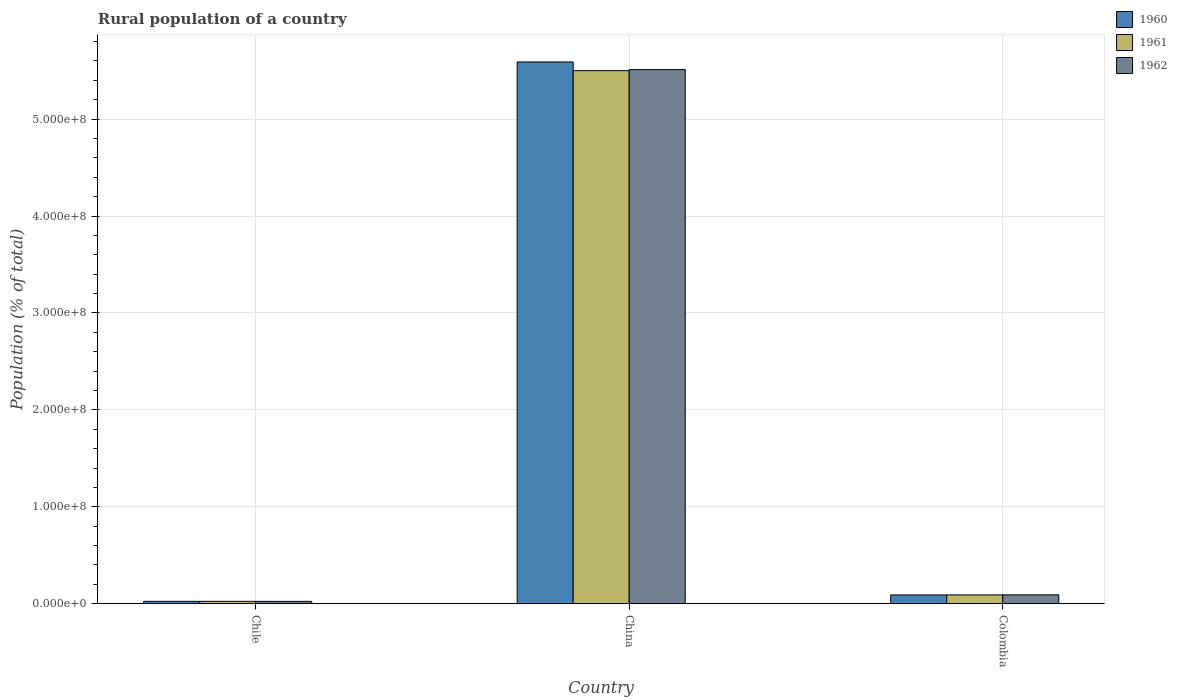How many different coloured bars are there?
Offer a terse response. 3. How many groups of bars are there?
Keep it short and to the point. 3. How many bars are there on the 3rd tick from the left?
Provide a succinct answer. 3. How many bars are there on the 1st tick from the right?
Offer a terse response. 3. What is the label of the 1st group of bars from the left?
Your answer should be compact. Chile. In how many cases, is the number of bars for a given country not equal to the number of legend labels?
Ensure brevity in your answer.  0. What is the rural population in 1961 in China?
Offer a terse response. 5.50e+08. Across all countries, what is the maximum rural population in 1962?
Provide a succinct answer. 5.51e+08. Across all countries, what is the minimum rural population in 1961?
Offer a terse response. 2.47e+06. In which country was the rural population in 1962 maximum?
Your answer should be very brief. China. In which country was the rural population in 1960 minimum?
Provide a succinct answer. Chile. What is the total rural population in 1962 in the graph?
Keep it short and to the point. 5.63e+08. What is the difference between the rural population in 1960 in Chile and that in China?
Offer a very short reply. -5.57e+08. What is the difference between the rural population in 1961 in Chile and the rural population in 1962 in China?
Give a very brief answer. -5.49e+08. What is the average rural population in 1960 per country?
Offer a very short reply. 1.90e+08. What is the difference between the rural population of/in 1962 and rural population of/in 1960 in Chile?
Your answer should be compact. -1.35e+04. In how many countries, is the rural population in 1962 greater than 160000000 %?
Your response must be concise. 1. What is the ratio of the rural population in 1960 in Chile to that in Colombia?
Provide a succinct answer. 0.27. Is the rural population in 1960 in China less than that in Colombia?
Offer a very short reply. No. Is the difference between the rural population in 1962 in China and Colombia greater than the difference between the rural population in 1960 in China and Colombia?
Provide a short and direct response. No. What is the difference between the highest and the second highest rural population in 1960?
Make the answer very short. 5.57e+08. What is the difference between the highest and the lowest rural population in 1960?
Keep it short and to the point. 5.57e+08. Is the sum of the rural population in 1961 in Chile and Colombia greater than the maximum rural population in 1960 across all countries?
Ensure brevity in your answer.  No. Are all the bars in the graph horizontal?
Make the answer very short. No. How many countries are there in the graph?
Provide a short and direct response. 3. Are the values on the major ticks of Y-axis written in scientific E-notation?
Provide a short and direct response. Yes. What is the title of the graph?
Provide a succinct answer. Rural population of a country. What is the label or title of the Y-axis?
Keep it short and to the point. Population (% of total). What is the Population (% of total) of 1960 in Chile?
Your answer should be very brief. 2.48e+06. What is the Population (% of total) of 1961 in Chile?
Offer a very short reply. 2.47e+06. What is the Population (% of total) of 1962 in Chile?
Keep it short and to the point. 2.46e+06. What is the Population (% of total) in 1960 in China?
Your response must be concise. 5.59e+08. What is the Population (% of total) in 1961 in China?
Your response must be concise. 5.50e+08. What is the Population (% of total) of 1962 in China?
Provide a succinct answer. 5.51e+08. What is the Population (% of total) in 1960 in Colombia?
Provide a succinct answer. 9.06e+06. What is the Population (% of total) in 1961 in Colombia?
Your answer should be compact. 9.11e+06. What is the Population (% of total) in 1962 in Colombia?
Ensure brevity in your answer.  9.17e+06. Across all countries, what is the maximum Population (% of total) of 1960?
Your response must be concise. 5.59e+08. Across all countries, what is the maximum Population (% of total) of 1961?
Provide a short and direct response. 5.50e+08. Across all countries, what is the maximum Population (% of total) in 1962?
Keep it short and to the point. 5.51e+08. Across all countries, what is the minimum Population (% of total) of 1960?
Your answer should be very brief. 2.48e+06. Across all countries, what is the minimum Population (% of total) in 1961?
Offer a terse response. 2.47e+06. Across all countries, what is the minimum Population (% of total) of 1962?
Make the answer very short. 2.46e+06. What is the total Population (% of total) of 1960 in the graph?
Offer a very short reply. 5.71e+08. What is the total Population (% of total) in 1961 in the graph?
Offer a very short reply. 5.62e+08. What is the total Population (% of total) of 1962 in the graph?
Offer a very short reply. 5.63e+08. What is the difference between the Population (% of total) of 1960 in Chile and that in China?
Your answer should be very brief. -5.57e+08. What is the difference between the Population (% of total) of 1961 in Chile and that in China?
Make the answer very short. -5.48e+08. What is the difference between the Population (% of total) of 1962 in Chile and that in China?
Your answer should be compact. -5.49e+08. What is the difference between the Population (% of total) of 1960 in Chile and that in Colombia?
Provide a short and direct response. -6.58e+06. What is the difference between the Population (% of total) of 1961 in Chile and that in Colombia?
Your response must be concise. -6.65e+06. What is the difference between the Population (% of total) of 1962 in Chile and that in Colombia?
Keep it short and to the point. -6.70e+06. What is the difference between the Population (% of total) in 1960 in China and that in Colombia?
Provide a short and direct response. 5.50e+08. What is the difference between the Population (% of total) of 1961 in China and that in Colombia?
Provide a succinct answer. 5.41e+08. What is the difference between the Population (% of total) of 1962 in China and that in Colombia?
Ensure brevity in your answer.  5.42e+08. What is the difference between the Population (% of total) of 1960 in Chile and the Population (% of total) of 1961 in China?
Keep it short and to the point. -5.48e+08. What is the difference between the Population (% of total) of 1960 in Chile and the Population (% of total) of 1962 in China?
Your response must be concise. -5.49e+08. What is the difference between the Population (% of total) in 1961 in Chile and the Population (% of total) in 1962 in China?
Your answer should be very brief. -5.49e+08. What is the difference between the Population (% of total) of 1960 in Chile and the Population (% of total) of 1961 in Colombia?
Your answer should be compact. -6.64e+06. What is the difference between the Population (% of total) in 1960 in Chile and the Population (% of total) in 1962 in Colombia?
Provide a succinct answer. -6.69e+06. What is the difference between the Population (% of total) in 1961 in Chile and the Population (% of total) in 1962 in Colombia?
Give a very brief answer. -6.70e+06. What is the difference between the Population (% of total) of 1960 in China and the Population (% of total) of 1961 in Colombia?
Your answer should be very brief. 5.50e+08. What is the difference between the Population (% of total) in 1960 in China and the Population (% of total) in 1962 in Colombia?
Give a very brief answer. 5.50e+08. What is the difference between the Population (% of total) of 1961 in China and the Population (% of total) of 1962 in Colombia?
Provide a succinct answer. 5.41e+08. What is the average Population (% of total) of 1960 per country?
Give a very brief answer. 1.90e+08. What is the average Population (% of total) in 1961 per country?
Provide a short and direct response. 1.87e+08. What is the average Population (% of total) of 1962 per country?
Provide a succinct answer. 1.88e+08. What is the difference between the Population (% of total) in 1960 and Population (% of total) in 1961 in Chile?
Keep it short and to the point. 7686. What is the difference between the Population (% of total) in 1960 and Population (% of total) in 1962 in Chile?
Make the answer very short. 1.35e+04. What is the difference between the Population (% of total) in 1961 and Population (% of total) in 1962 in Chile?
Provide a succinct answer. 5800. What is the difference between the Population (% of total) of 1960 and Population (% of total) of 1961 in China?
Your answer should be very brief. 8.98e+06. What is the difference between the Population (% of total) in 1960 and Population (% of total) in 1962 in China?
Offer a terse response. 7.90e+06. What is the difference between the Population (% of total) of 1961 and Population (% of total) of 1962 in China?
Your response must be concise. -1.08e+06. What is the difference between the Population (% of total) of 1960 and Population (% of total) of 1961 in Colombia?
Your response must be concise. -5.61e+04. What is the difference between the Population (% of total) of 1960 and Population (% of total) of 1962 in Colombia?
Provide a short and direct response. -1.06e+05. What is the difference between the Population (% of total) of 1961 and Population (% of total) of 1962 in Colombia?
Offer a very short reply. -5.03e+04. What is the ratio of the Population (% of total) in 1960 in Chile to that in China?
Ensure brevity in your answer.  0. What is the ratio of the Population (% of total) in 1961 in Chile to that in China?
Make the answer very short. 0. What is the ratio of the Population (% of total) of 1962 in Chile to that in China?
Offer a very short reply. 0. What is the ratio of the Population (% of total) in 1960 in Chile to that in Colombia?
Make the answer very short. 0.27. What is the ratio of the Population (% of total) of 1961 in Chile to that in Colombia?
Offer a very short reply. 0.27. What is the ratio of the Population (% of total) in 1962 in Chile to that in Colombia?
Provide a succinct answer. 0.27. What is the ratio of the Population (% of total) in 1960 in China to that in Colombia?
Provide a short and direct response. 61.71. What is the ratio of the Population (% of total) in 1961 in China to that in Colombia?
Your response must be concise. 60.34. What is the ratio of the Population (% of total) of 1962 in China to that in Colombia?
Provide a short and direct response. 60.13. What is the difference between the highest and the second highest Population (% of total) in 1960?
Your answer should be compact. 5.50e+08. What is the difference between the highest and the second highest Population (% of total) in 1961?
Your answer should be very brief. 5.41e+08. What is the difference between the highest and the second highest Population (% of total) in 1962?
Your response must be concise. 5.42e+08. What is the difference between the highest and the lowest Population (% of total) of 1960?
Provide a succinct answer. 5.57e+08. What is the difference between the highest and the lowest Population (% of total) in 1961?
Give a very brief answer. 5.48e+08. What is the difference between the highest and the lowest Population (% of total) of 1962?
Keep it short and to the point. 5.49e+08. 